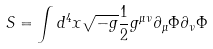Convert formula to latex. <formula><loc_0><loc_0><loc_500><loc_500>S = \int d ^ { 4 } x \sqrt { - g } \frac { 1 } { 2 } g ^ { \mu \nu } \partial _ { \mu } \Phi \partial _ { \nu } \Phi</formula> 